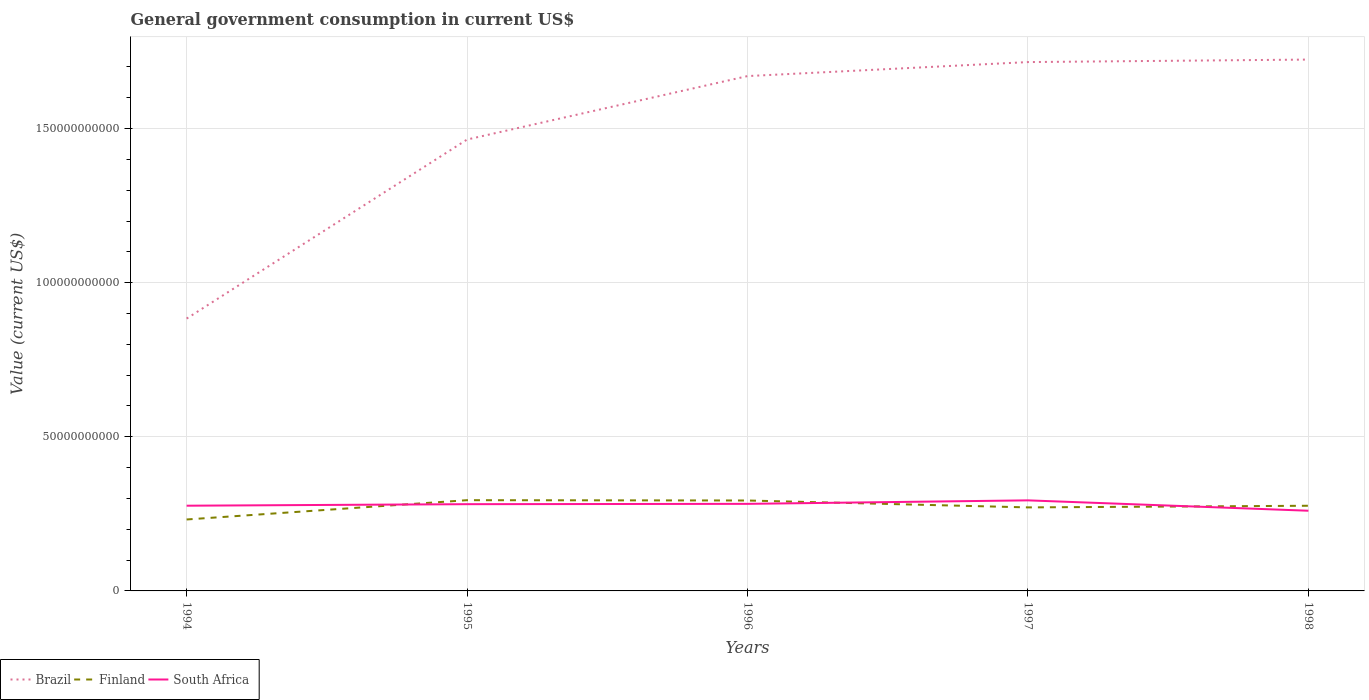Across all years, what is the maximum government conusmption in Finland?
Your response must be concise. 2.32e+1. What is the total government conusmption in Brazil in the graph?
Ensure brevity in your answer.  -8.40e+1. What is the difference between the highest and the second highest government conusmption in Brazil?
Your response must be concise. 8.40e+1. Is the government conusmption in South Africa strictly greater than the government conusmption in Finland over the years?
Your response must be concise. No. How many years are there in the graph?
Ensure brevity in your answer.  5. Does the graph contain grids?
Make the answer very short. Yes. Where does the legend appear in the graph?
Give a very brief answer. Bottom left. How many legend labels are there?
Your answer should be very brief. 3. What is the title of the graph?
Provide a short and direct response. General government consumption in current US$. Does "Oman" appear as one of the legend labels in the graph?
Offer a terse response. No. What is the label or title of the X-axis?
Ensure brevity in your answer.  Years. What is the label or title of the Y-axis?
Provide a short and direct response. Value (current US$). What is the Value (current US$) in Brazil in 1994?
Offer a terse response. 8.84e+1. What is the Value (current US$) in Finland in 1994?
Provide a succinct answer. 2.32e+1. What is the Value (current US$) in South Africa in 1994?
Give a very brief answer. 2.76e+1. What is the Value (current US$) in Brazil in 1995?
Your answer should be very brief. 1.46e+11. What is the Value (current US$) of Finland in 1995?
Give a very brief answer. 2.94e+1. What is the Value (current US$) of South Africa in 1995?
Your answer should be compact. 2.81e+1. What is the Value (current US$) in Brazil in 1996?
Offer a very short reply. 1.67e+11. What is the Value (current US$) of Finland in 1996?
Give a very brief answer. 2.93e+1. What is the Value (current US$) of South Africa in 1996?
Your answer should be compact. 2.82e+1. What is the Value (current US$) of Brazil in 1997?
Provide a short and direct response. 1.72e+11. What is the Value (current US$) of Finland in 1997?
Offer a terse response. 2.71e+1. What is the Value (current US$) in South Africa in 1997?
Offer a terse response. 2.94e+1. What is the Value (current US$) in Brazil in 1998?
Give a very brief answer. 1.72e+11. What is the Value (current US$) of Finland in 1998?
Keep it short and to the point. 2.76e+1. What is the Value (current US$) in South Africa in 1998?
Your answer should be compact. 2.60e+1. Across all years, what is the maximum Value (current US$) of Brazil?
Give a very brief answer. 1.72e+11. Across all years, what is the maximum Value (current US$) in Finland?
Your answer should be very brief. 2.94e+1. Across all years, what is the maximum Value (current US$) in South Africa?
Offer a terse response. 2.94e+1. Across all years, what is the minimum Value (current US$) of Brazil?
Keep it short and to the point. 8.84e+1. Across all years, what is the minimum Value (current US$) in Finland?
Your response must be concise. 2.32e+1. Across all years, what is the minimum Value (current US$) in South Africa?
Provide a short and direct response. 2.60e+1. What is the total Value (current US$) in Brazil in the graph?
Give a very brief answer. 7.46e+11. What is the total Value (current US$) of Finland in the graph?
Give a very brief answer. 1.37e+11. What is the total Value (current US$) in South Africa in the graph?
Give a very brief answer. 1.39e+11. What is the difference between the Value (current US$) in Brazil in 1994 and that in 1995?
Your answer should be very brief. -5.81e+1. What is the difference between the Value (current US$) in Finland in 1994 and that in 1995?
Provide a short and direct response. -6.26e+09. What is the difference between the Value (current US$) of South Africa in 1994 and that in 1995?
Provide a succinct answer. -4.97e+08. What is the difference between the Value (current US$) of Brazil in 1994 and that in 1996?
Offer a terse response. -7.87e+1. What is the difference between the Value (current US$) in Finland in 1994 and that in 1996?
Give a very brief answer. -6.16e+09. What is the difference between the Value (current US$) of South Africa in 1994 and that in 1996?
Ensure brevity in your answer.  -6.00e+08. What is the difference between the Value (current US$) in Brazil in 1994 and that in 1997?
Your answer should be very brief. -8.32e+1. What is the difference between the Value (current US$) in Finland in 1994 and that in 1997?
Your answer should be very brief. -3.92e+09. What is the difference between the Value (current US$) of South Africa in 1994 and that in 1997?
Ensure brevity in your answer.  -1.74e+09. What is the difference between the Value (current US$) in Brazil in 1994 and that in 1998?
Keep it short and to the point. -8.40e+1. What is the difference between the Value (current US$) of Finland in 1994 and that in 1998?
Offer a very short reply. -4.45e+09. What is the difference between the Value (current US$) of South Africa in 1994 and that in 1998?
Offer a very short reply. 1.63e+09. What is the difference between the Value (current US$) in Brazil in 1995 and that in 1996?
Offer a very short reply. -2.06e+1. What is the difference between the Value (current US$) in Finland in 1995 and that in 1996?
Provide a short and direct response. 1.02e+08. What is the difference between the Value (current US$) in South Africa in 1995 and that in 1996?
Keep it short and to the point. -1.04e+08. What is the difference between the Value (current US$) in Brazil in 1995 and that in 1997?
Give a very brief answer. -2.51e+1. What is the difference between the Value (current US$) in Finland in 1995 and that in 1997?
Your response must be concise. 2.34e+09. What is the difference between the Value (current US$) of South Africa in 1995 and that in 1997?
Your answer should be compact. -1.24e+09. What is the difference between the Value (current US$) in Brazil in 1995 and that in 1998?
Make the answer very short. -2.59e+1. What is the difference between the Value (current US$) of Finland in 1995 and that in 1998?
Provide a short and direct response. 1.81e+09. What is the difference between the Value (current US$) in South Africa in 1995 and that in 1998?
Make the answer very short. 2.13e+09. What is the difference between the Value (current US$) in Brazil in 1996 and that in 1997?
Provide a short and direct response. -4.54e+09. What is the difference between the Value (current US$) of Finland in 1996 and that in 1997?
Your answer should be compact. 2.24e+09. What is the difference between the Value (current US$) in South Africa in 1996 and that in 1997?
Ensure brevity in your answer.  -1.14e+09. What is the difference between the Value (current US$) in Brazil in 1996 and that in 1998?
Your answer should be very brief. -5.36e+09. What is the difference between the Value (current US$) in Finland in 1996 and that in 1998?
Provide a succinct answer. 1.70e+09. What is the difference between the Value (current US$) in South Africa in 1996 and that in 1998?
Your response must be concise. 2.23e+09. What is the difference between the Value (current US$) of Brazil in 1997 and that in 1998?
Give a very brief answer. -8.13e+08. What is the difference between the Value (current US$) of Finland in 1997 and that in 1998?
Your answer should be compact. -5.34e+08. What is the difference between the Value (current US$) of South Africa in 1997 and that in 1998?
Keep it short and to the point. 3.37e+09. What is the difference between the Value (current US$) in Brazil in 1994 and the Value (current US$) in Finland in 1995?
Offer a terse response. 5.89e+1. What is the difference between the Value (current US$) of Brazil in 1994 and the Value (current US$) of South Africa in 1995?
Make the answer very short. 6.02e+1. What is the difference between the Value (current US$) in Finland in 1994 and the Value (current US$) in South Africa in 1995?
Make the answer very short. -4.96e+09. What is the difference between the Value (current US$) in Brazil in 1994 and the Value (current US$) in Finland in 1996?
Provide a succinct answer. 5.90e+1. What is the difference between the Value (current US$) in Brazil in 1994 and the Value (current US$) in South Africa in 1996?
Ensure brevity in your answer.  6.01e+1. What is the difference between the Value (current US$) of Finland in 1994 and the Value (current US$) of South Africa in 1996?
Ensure brevity in your answer.  -5.07e+09. What is the difference between the Value (current US$) in Brazil in 1994 and the Value (current US$) in Finland in 1997?
Your answer should be very brief. 6.13e+1. What is the difference between the Value (current US$) in Brazil in 1994 and the Value (current US$) in South Africa in 1997?
Provide a short and direct response. 5.90e+1. What is the difference between the Value (current US$) of Finland in 1994 and the Value (current US$) of South Africa in 1997?
Offer a very short reply. -6.20e+09. What is the difference between the Value (current US$) of Brazil in 1994 and the Value (current US$) of Finland in 1998?
Ensure brevity in your answer.  6.07e+1. What is the difference between the Value (current US$) of Brazil in 1994 and the Value (current US$) of South Africa in 1998?
Offer a terse response. 6.23e+1. What is the difference between the Value (current US$) of Finland in 1994 and the Value (current US$) of South Africa in 1998?
Keep it short and to the point. -2.84e+09. What is the difference between the Value (current US$) in Brazil in 1995 and the Value (current US$) in Finland in 1996?
Make the answer very short. 1.17e+11. What is the difference between the Value (current US$) in Brazil in 1995 and the Value (current US$) in South Africa in 1996?
Make the answer very short. 1.18e+11. What is the difference between the Value (current US$) in Finland in 1995 and the Value (current US$) in South Africa in 1996?
Your answer should be very brief. 1.19e+09. What is the difference between the Value (current US$) in Brazil in 1995 and the Value (current US$) in Finland in 1997?
Make the answer very short. 1.19e+11. What is the difference between the Value (current US$) in Brazil in 1995 and the Value (current US$) in South Africa in 1997?
Keep it short and to the point. 1.17e+11. What is the difference between the Value (current US$) in Finland in 1995 and the Value (current US$) in South Africa in 1997?
Provide a short and direct response. 5.53e+07. What is the difference between the Value (current US$) in Brazil in 1995 and the Value (current US$) in Finland in 1998?
Provide a succinct answer. 1.19e+11. What is the difference between the Value (current US$) in Brazil in 1995 and the Value (current US$) in South Africa in 1998?
Offer a very short reply. 1.20e+11. What is the difference between the Value (current US$) of Finland in 1995 and the Value (current US$) of South Africa in 1998?
Your response must be concise. 3.42e+09. What is the difference between the Value (current US$) in Brazil in 1996 and the Value (current US$) in Finland in 1997?
Provide a short and direct response. 1.40e+11. What is the difference between the Value (current US$) in Brazil in 1996 and the Value (current US$) in South Africa in 1997?
Keep it short and to the point. 1.38e+11. What is the difference between the Value (current US$) of Finland in 1996 and the Value (current US$) of South Africa in 1997?
Offer a terse response. -4.64e+07. What is the difference between the Value (current US$) in Brazil in 1996 and the Value (current US$) in Finland in 1998?
Provide a succinct answer. 1.39e+11. What is the difference between the Value (current US$) in Brazil in 1996 and the Value (current US$) in South Africa in 1998?
Offer a terse response. 1.41e+11. What is the difference between the Value (current US$) of Finland in 1996 and the Value (current US$) of South Africa in 1998?
Make the answer very short. 3.32e+09. What is the difference between the Value (current US$) of Brazil in 1997 and the Value (current US$) of Finland in 1998?
Your answer should be very brief. 1.44e+11. What is the difference between the Value (current US$) in Brazil in 1997 and the Value (current US$) in South Africa in 1998?
Offer a very short reply. 1.46e+11. What is the difference between the Value (current US$) in Finland in 1997 and the Value (current US$) in South Africa in 1998?
Make the answer very short. 1.08e+09. What is the average Value (current US$) of Brazil per year?
Your answer should be very brief. 1.49e+11. What is the average Value (current US$) in Finland per year?
Offer a very short reply. 2.73e+1. What is the average Value (current US$) in South Africa per year?
Give a very brief answer. 2.79e+1. In the year 1994, what is the difference between the Value (current US$) of Brazil and Value (current US$) of Finland?
Give a very brief answer. 6.52e+1. In the year 1994, what is the difference between the Value (current US$) of Brazil and Value (current US$) of South Africa?
Your answer should be very brief. 6.07e+1. In the year 1994, what is the difference between the Value (current US$) of Finland and Value (current US$) of South Africa?
Your response must be concise. -4.47e+09. In the year 1995, what is the difference between the Value (current US$) in Brazil and Value (current US$) in Finland?
Offer a very short reply. 1.17e+11. In the year 1995, what is the difference between the Value (current US$) of Brazil and Value (current US$) of South Africa?
Give a very brief answer. 1.18e+11. In the year 1995, what is the difference between the Value (current US$) of Finland and Value (current US$) of South Africa?
Make the answer very short. 1.30e+09. In the year 1996, what is the difference between the Value (current US$) of Brazil and Value (current US$) of Finland?
Offer a terse response. 1.38e+11. In the year 1996, what is the difference between the Value (current US$) of Brazil and Value (current US$) of South Africa?
Keep it short and to the point. 1.39e+11. In the year 1996, what is the difference between the Value (current US$) of Finland and Value (current US$) of South Africa?
Provide a short and direct response. 1.09e+09. In the year 1997, what is the difference between the Value (current US$) of Brazil and Value (current US$) of Finland?
Offer a very short reply. 1.44e+11. In the year 1997, what is the difference between the Value (current US$) of Brazil and Value (current US$) of South Africa?
Offer a very short reply. 1.42e+11. In the year 1997, what is the difference between the Value (current US$) of Finland and Value (current US$) of South Africa?
Give a very brief answer. -2.28e+09. In the year 1998, what is the difference between the Value (current US$) in Brazil and Value (current US$) in Finland?
Your answer should be very brief. 1.45e+11. In the year 1998, what is the difference between the Value (current US$) in Brazil and Value (current US$) in South Africa?
Your answer should be very brief. 1.46e+11. In the year 1998, what is the difference between the Value (current US$) of Finland and Value (current US$) of South Africa?
Your answer should be compact. 1.62e+09. What is the ratio of the Value (current US$) in Brazil in 1994 to that in 1995?
Offer a very short reply. 0.6. What is the ratio of the Value (current US$) of Finland in 1994 to that in 1995?
Ensure brevity in your answer.  0.79. What is the ratio of the Value (current US$) in South Africa in 1994 to that in 1995?
Provide a short and direct response. 0.98. What is the ratio of the Value (current US$) of Brazil in 1994 to that in 1996?
Your response must be concise. 0.53. What is the ratio of the Value (current US$) in Finland in 1994 to that in 1996?
Offer a terse response. 0.79. What is the ratio of the Value (current US$) in South Africa in 1994 to that in 1996?
Provide a short and direct response. 0.98. What is the ratio of the Value (current US$) of Brazil in 1994 to that in 1997?
Provide a succinct answer. 0.52. What is the ratio of the Value (current US$) in Finland in 1994 to that in 1997?
Offer a very short reply. 0.86. What is the ratio of the Value (current US$) of South Africa in 1994 to that in 1997?
Ensure brevity in your answer.  0.94. What is the ratio of the Value (current US$) of Brazil in 1994 to that in 1998?
Your answer should be compact. 0.51. What is the ratio of the Value (current US$) of Finland in 1994 to that in 1998?
Provide a succinct answer. 0.84. What is the ratio of the Value (current US$) of South Africa in 1994 to that in 1998?
Make the answer very short. 1.06. What is the ratio of the Value (current US$) of Brazil in 1995 to that in 1996?
Give a very brief answer. 0.88. What is the ratio of the Value (current US$) of Finland in 1995 to that in 1996?
Your answer should be compact. 1. What is the ratio of the Value (current US$) in South Africa in 1995 to that in 1996?
Provide a short and direct response. 1. What is the ratio of the Value (current US$) in Brazil in 1995 to that in 1997?
Offer a very short reply. 0.85. What is the ratio of the Value (current US$) of Finland in 1995 to that in 1997?
Your response must be concise. 1.09. What is the ratio of the Value (current US$) in South Africa in 1995 to that in 1997?
Make the answer very short. 0.96. What is the ratio of the Value (current US$) in Brazil in 1995 to that in 1998?
Make the answer very short. 0.85. What is the ratio of the Value (current US$) in Finland in 1995 to that in 1998?
Provide a short and direct response. 1.07. What is the ratio of the Value (current US$) of South Africa in 1995 to that in 1998?
Your answer should be very brief. 1.08. What is the ratio of the Value (current US$) of Brazil in 1996 to that in 1997?
Ensure brevity in your answer.  0.97. What is the ratio of the Value (current US$) in Finland in 1996 to that in 1997?
Keep it short and to the point. 1.08. What is the ratio of the Value (current US$) of South Africa in 1996 to that in 1997?
Provide a succinct answer. 0.96. What is the ratio of the Value (current US$) of Brazil in 1996 to that in 1998?
Make the answer very short. 0.97. What is the ratio of the Value (current US$) in Finland in 1996 to that in 1998?
Ensure brevity in your answer.  1.06. What is the ratio of the Value (current US$) of South Africa in 1996 to that in 1998?
Keep it short and to the point. 1.09. What is the ratio of the Value (current US$) in Finland in 1997 to that in 1998?
Your answer should be compact. 0.98. What is the ratio of the Value (current US$) of South Africa in 1997 to that in 1998?
Your answer should be compact. 1.13. What is the difference between the highest and the second highest Value (current US$) in Brazil?
Your response must be concise. 8.13e+08. What is the difference between the highest and the second highest Value (current US$) of Finland?
Keep it short and to the point. 1.02e+08. What is the difference between the highest and the second highest Value (current US$) of South Africa?
Your response must be concise. 1.14e+09. What is the difference between the highest and the lowest Value (current US$) of Brazil?
Your answer should be very brief. 8.40e+1. What is the difference between the highest and the lowest Value (current US$) of Finland?
Offer a terse response. 6.26e+09. What is the difference between the highest and the lowest Value (current US$) in South Africa?
Offer a very short reply. 3.37e+09. 